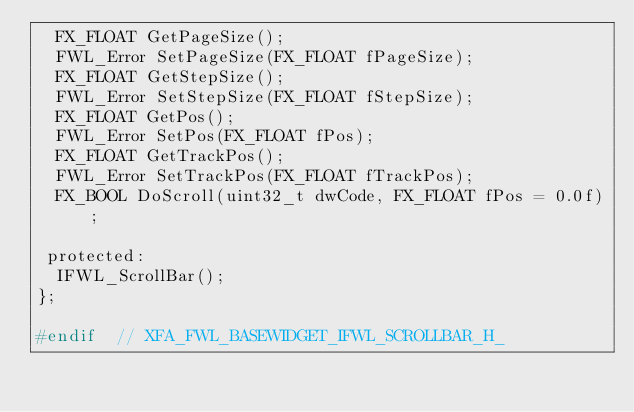<code> <loc_0><loc_0><loc_500><loc_500><_C_>  FX_FLOAT GetPageSize();
  FWL_Error SetPageSize(FX_FLOAT fPageSize);
  FX_FLOAT GetStepSize();
  FWL_Error SetStepSize(FX_FLOAT fStepSize);
  FX_FLOAT GetPos();
  FWL_Error SetPos(FX_FLOAT fPos);
  FX_FLOAT GetTrackPos();
  FWL_Error SetTrackPos(FX_FLOAT fTrackPos);
  FX_BOOL DoScroll(uint32_t dwCode, FX_FLOAT fPos = 0.0f);

 protected:
  IFWL_ScrollBar();
};

#endif  // XFA_FWL_BASEWIDGET_IFWL_SCROLLBAR_H_
</code> 